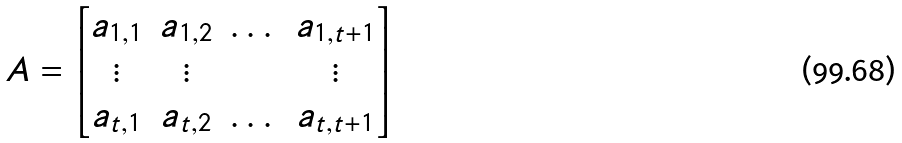Convert formula to latex. <formula><loc_0><loc_0><loc_500><loc_500>A = \begin{bmatrix} a _ { 1 , 1 } & a _ { 1 , 2 } & \dots & a _ { 1 , t + 1 } \\ \vdots & \vdots & & \vdots \\ a _ { t , 1 } & a _ { t , 2 } & \dots & a _ { t , t + 1 } \end{bmatrix}</formula> 